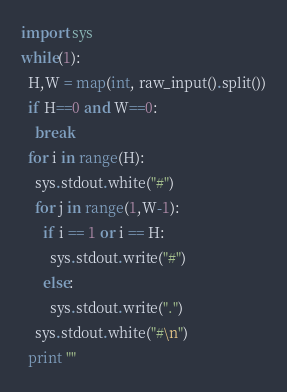<code> <loc_0><loc_0><loc_500><loc_500><_Python_>import sys
while(1):
  H,W = map(int, raw_input().split())
  if H==0 and W==0:
    break
  for i in range(H):
    sys.stdout.white("#")
    for j in range(1,W-1):
      if i == 1 or i == H:
        sys.stdout.write("#")
      else:
        sys.stdout.write(".")
    sys.stdout.white("#\n")
  print ""    </code> 